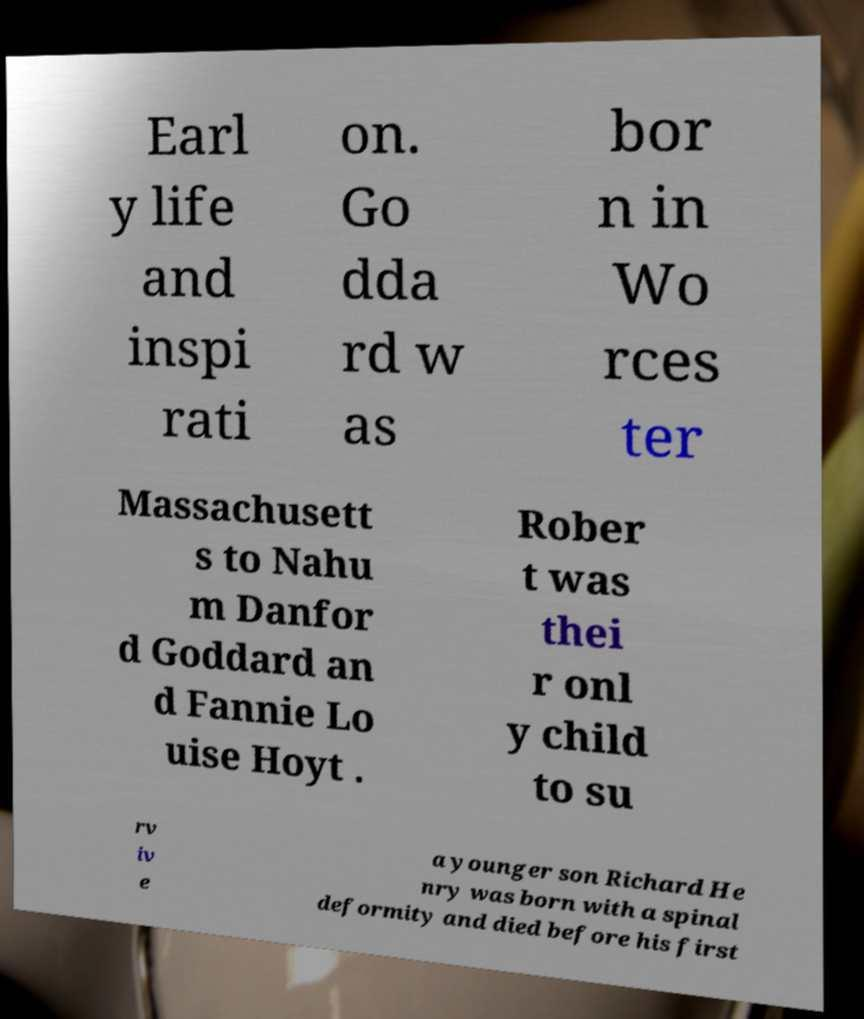Could you extract and type out the text from this image? Earl y life and inspi rati on. Go dda rd w as bor n in Wo rces ter Massachusett s to Nahu m Danfor d Goddard an d Fannie Lo uise Hoyt . Rober t was thei r onl y child to su rv iv e a younger son Richard He nry was born with a spinal deformity and died before his first 